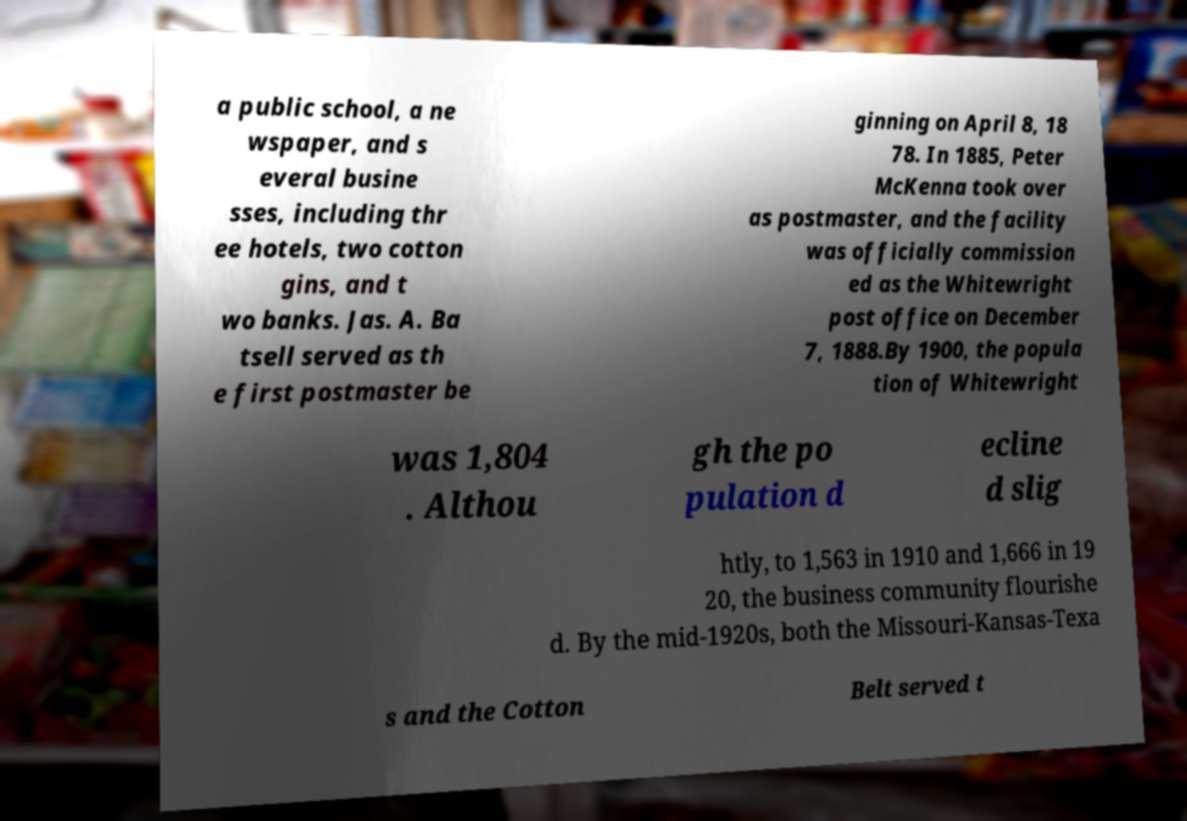Please read and relay the text visible in this image. What does it say? a public school, a ne wspaper, and s everal busine sses, including thr ee hotels, two cotton gins, and t wo banks. Jas. A. Ba tsell served as th e first postmaster be ginning on April 8, 18 78. In 1885, Peter McKenna took over as postmaster, and the facility was officially commission ed as the Whitewright post office on December 7, 1888.By 1900, the popula tion of Whitewright was 1,804 . Althou gh the po pulation d ecline d slig htly, to 1,563 in 1910 and 1,666 in 19 20, the business community flourishe d. By the mid-1920s, both the Missouri-Kansas-Texa s and the Cotton Belt served t 